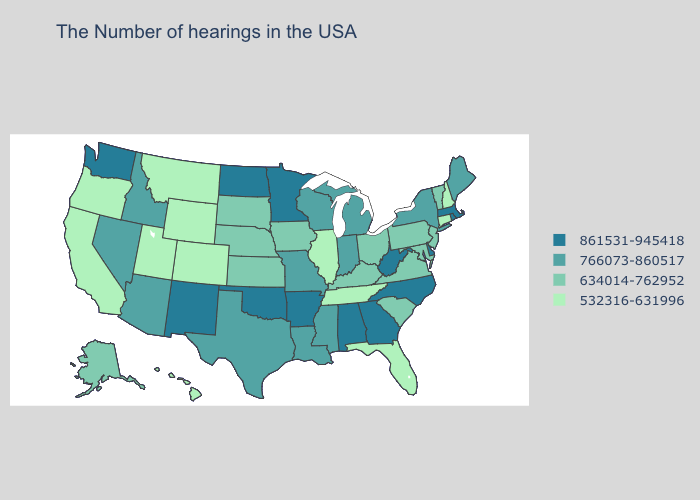Does the map have missing data?
Write a very short answer. No. Does Tennessee have the lowest value in the South?
Write a very short answer. Yes. What is the highest value in states that border Kansas?
Keep it brief. 861531-945418. What is the lowest value in the West?
Short answer required. 532316-631996. Among the states that border Vermont , does New York have the highest value?
Quick response, please. No. Does the map have missing data?
Quick response, please. No. Is the legend a continuous bar?
Keep it brief. No. Does Michigan have a higher value than Idaho?
Keep it brief. No. Name the states that have a value in the range 861531-945418?
Short answer required. Massachusetts, Rhode Island, Delaware, North Carolina, West Virginia, Georgia, Alabama, Arkansas, Minnesota, Oklahoma, North Dakota, New Mexico, Washington. Does the map have missing data?
Write a very short answer. No. Does the map have missing data?
Write a very short answer. No. Name the states that have a value in the range 861531-945418?
Be succinct. Massachusetts, Rhode Island, Delaware, North Carolina, West Virginia, Georgia, Alabama, Arkansas, Minnesota, Oklahoma, North Dakota, New Mexico, Washington. What is the value of Maryland?
Write a very short answer. 634014-762952. Name the states that have a value in the range 766073-860517?
Short answer required. Maine, New York, Michigan, Indiana, Wisconsin, Mississippi, Louisiana, Missouri, Texas, Arizona, Idaho, Nevada. What is the value of Michigan?
Quick response, please. 766073-860517. 